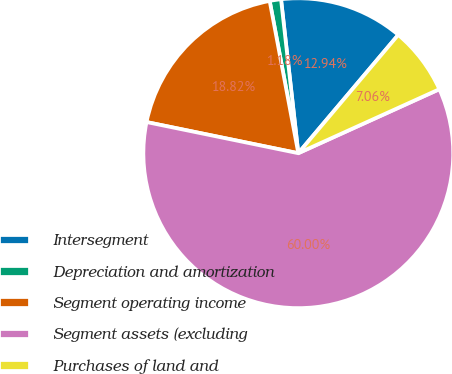Convert chart. <chart><loc_0><loc_0><loc_500><loc_500><pie_chart><fcel>Intersegment<fcel>Depreciation and amortization<fcel>Segment operating income<fcel>Segment assets (excluding<fcel>Purchases of land and<nl><fcel>12.94%<fcel>1.18%<fcel>18.82%<fcel>60.0%<fcel>7.06%<nl></chart> 